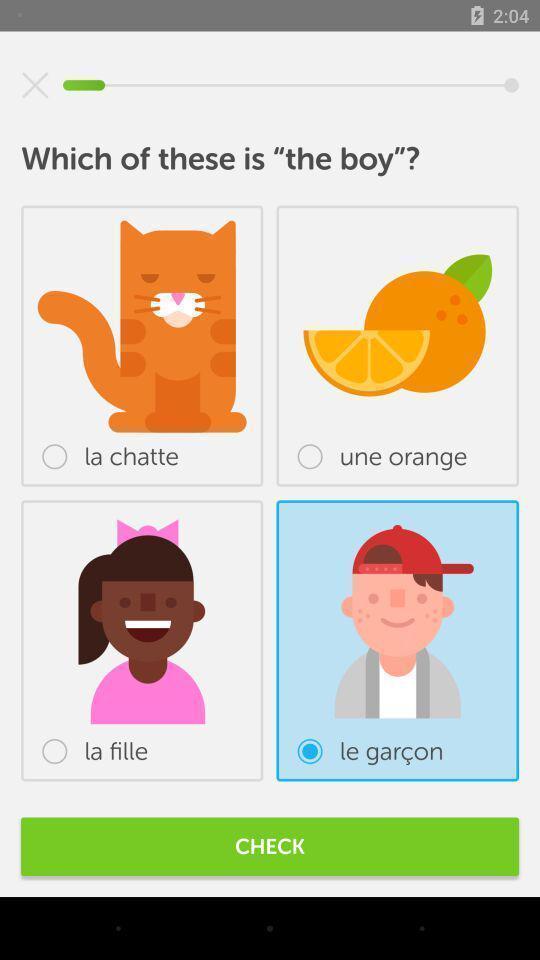Provide a detailed account of this screenshot. Page with question and options for language learning app. 